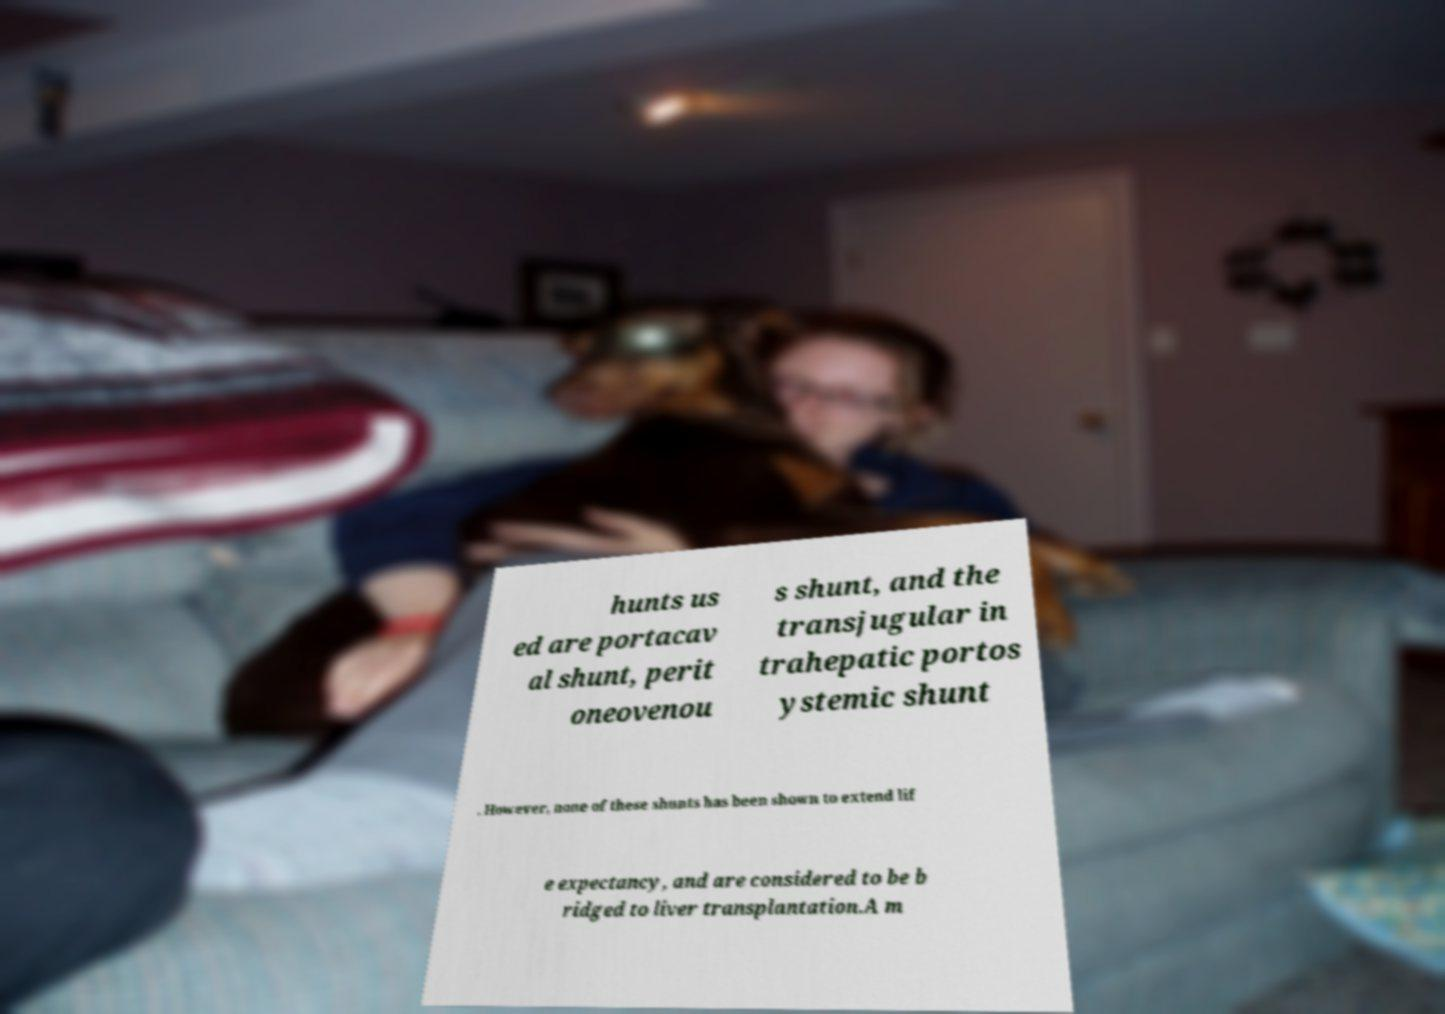Can you accurately transcribe the text from the provided image for me? hunts us ed are portacav al shunt, perit oneovenou s shunt, and the transjugular in trahepatic portos ystemic shunt . However, none of these shunts has been shown to extend lif e expectancy, and are considered to be b ridged to liver transplantation.A m 